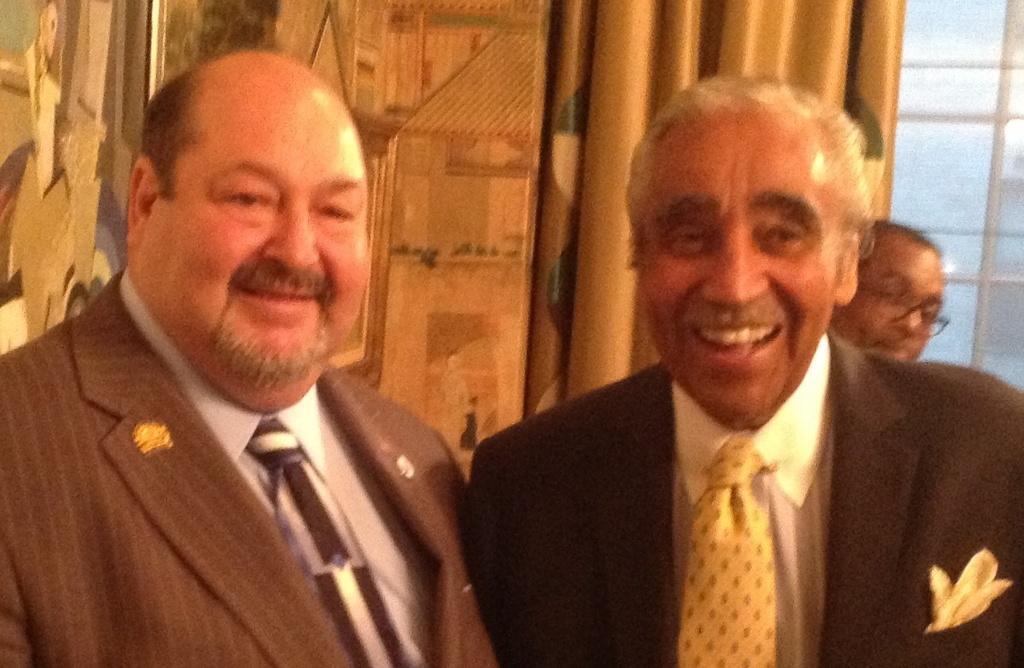In one or two sentences, can you explain what this image depicts? In this image I see 3 men and I see these 2 are wearing suits and both of them are smiling and I see the window glasses over here and I see the curtain which is of golden in color. 